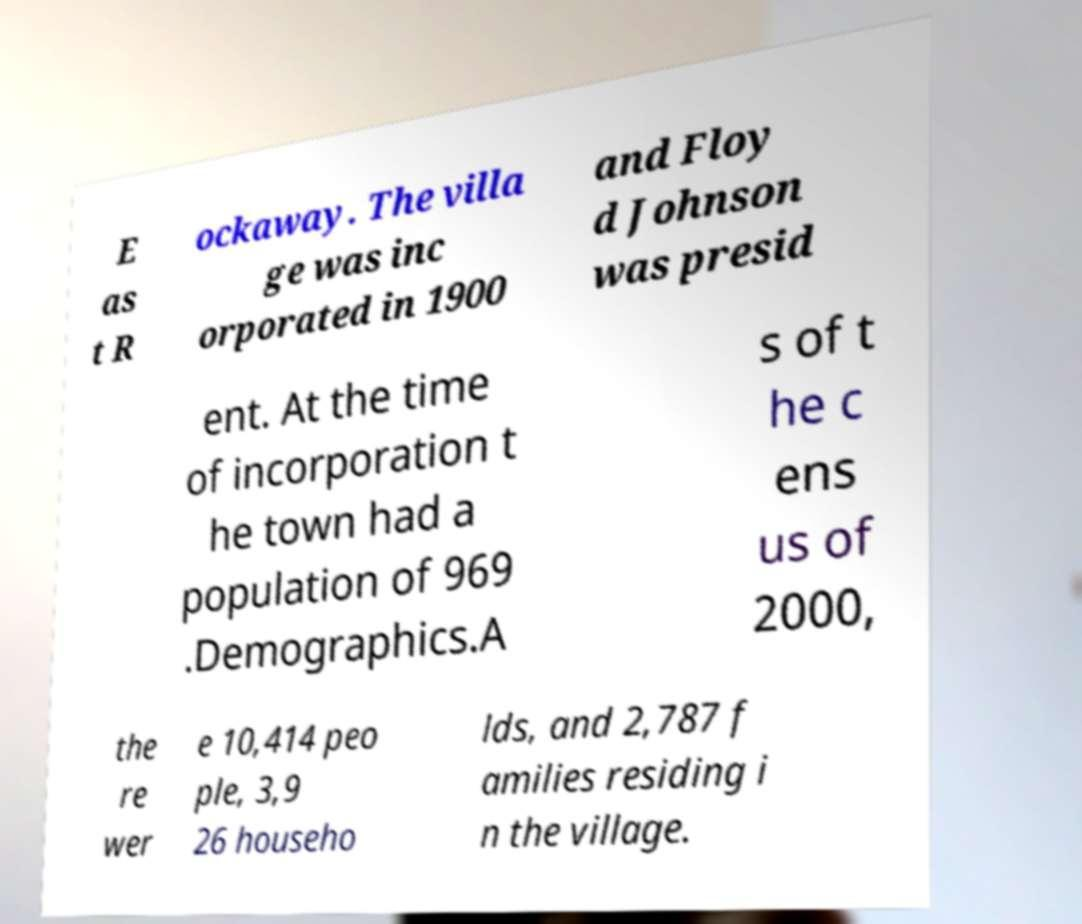Could you extract and type out the text from this image? E as t R ockaway. The villa ge was inc orporated in 1900 and Floy d Johnson was presid ent. At the time of incorporation t he town had a population of 969 .Demographics.A s of t he c ens us of 2000, the re wer e 10,414 peo ple, 3,9 26 househo lds, and 2,787 f amilies residing i n the village. 